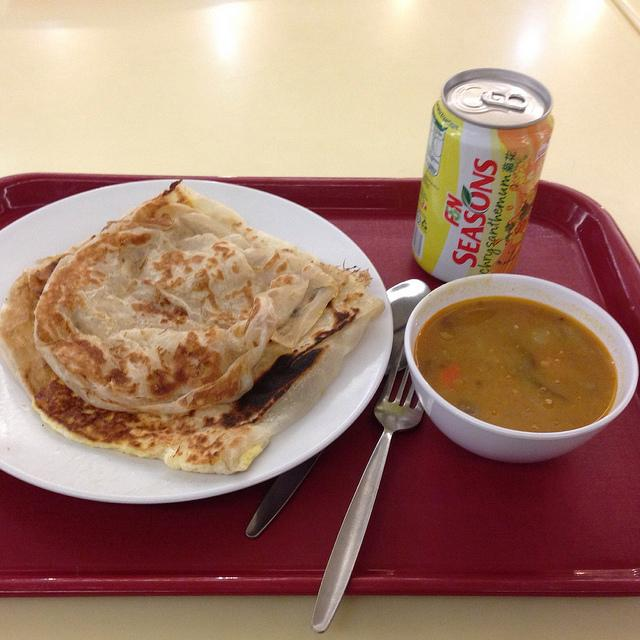Which item is probably the coldest? Please explain your reasoning. can. Most cans are stored in the fridge. 